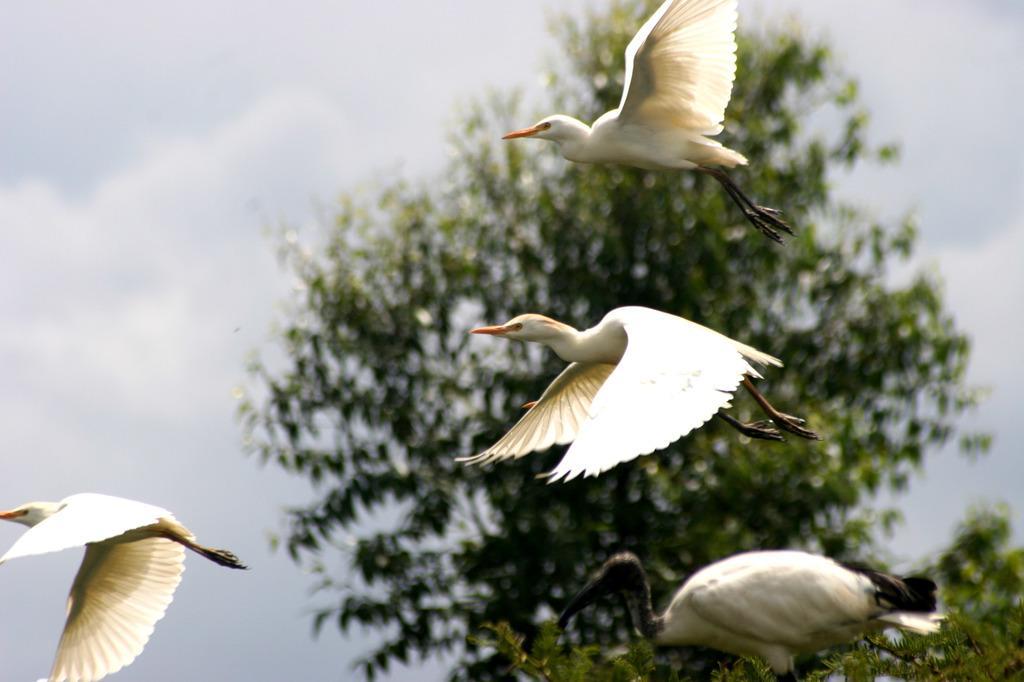How would you summarize this image in a sentence or two? In the image there are few birds flying in the air and behind its tree and above its sky with clouds. 